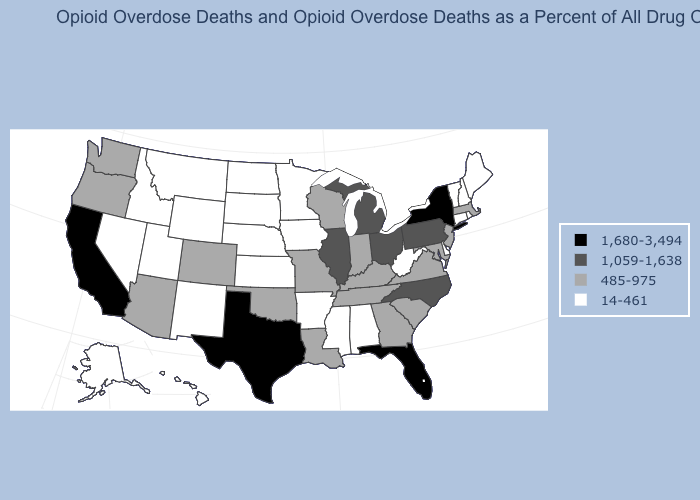What is the value of Ohio?
Keep it brief. 1,059-1,638. Which states have the lowest value in the USA?
Quick response, please. Alabama, Alaska, Arkansas, Connecticut, Delaware, Hawaii, Idaho, Iowa, Kansas, Maine, Minnesota, Mississippi, Montana, Nebraska, Nevada, New Hampshire, New Mexico, North Dakota, Rhode Island, South Dakota, Utah, Vermont, West Virginia, Wyoming. Among the states that border New Jersey , does New York have the highest value?
Quick response, please. Yes. Among the states that border Rhode Island , does Connecticut have the highest value?
Be succinct. No. Does Rhode Island have a lower value than New York?
Write a very short answer. Yes. Name the states that have a value in the range 1,680-3,494?
Give a very brief answer. California, Florida, New York, Texas. What is the value of Alabama?
Be succinct. 14-461. Among the states that border Georgia , does South Carolina have the lowest value?
Be succinct. No. Does Georgia have the lowest value in the USA?
Answer briefly. No. What is the lowest value in the West?
Concise answer only. 14-461. Among the states that border Nebraska , which have the lowest value?
Give a very brief answer. Iowa, Kansas, South Dakota, Wyoming. What is the value of Illinois?
Quick response, please. 1,059-1,638. Among the states that border Idaho , does Washington have the highest value?
Be succinct. Yes. Which states have the highest value in the USA?
Be succinct. California, Florida, New York, Texas. Does Colorado have the same value as Hawaii?
Be succinct. No. 